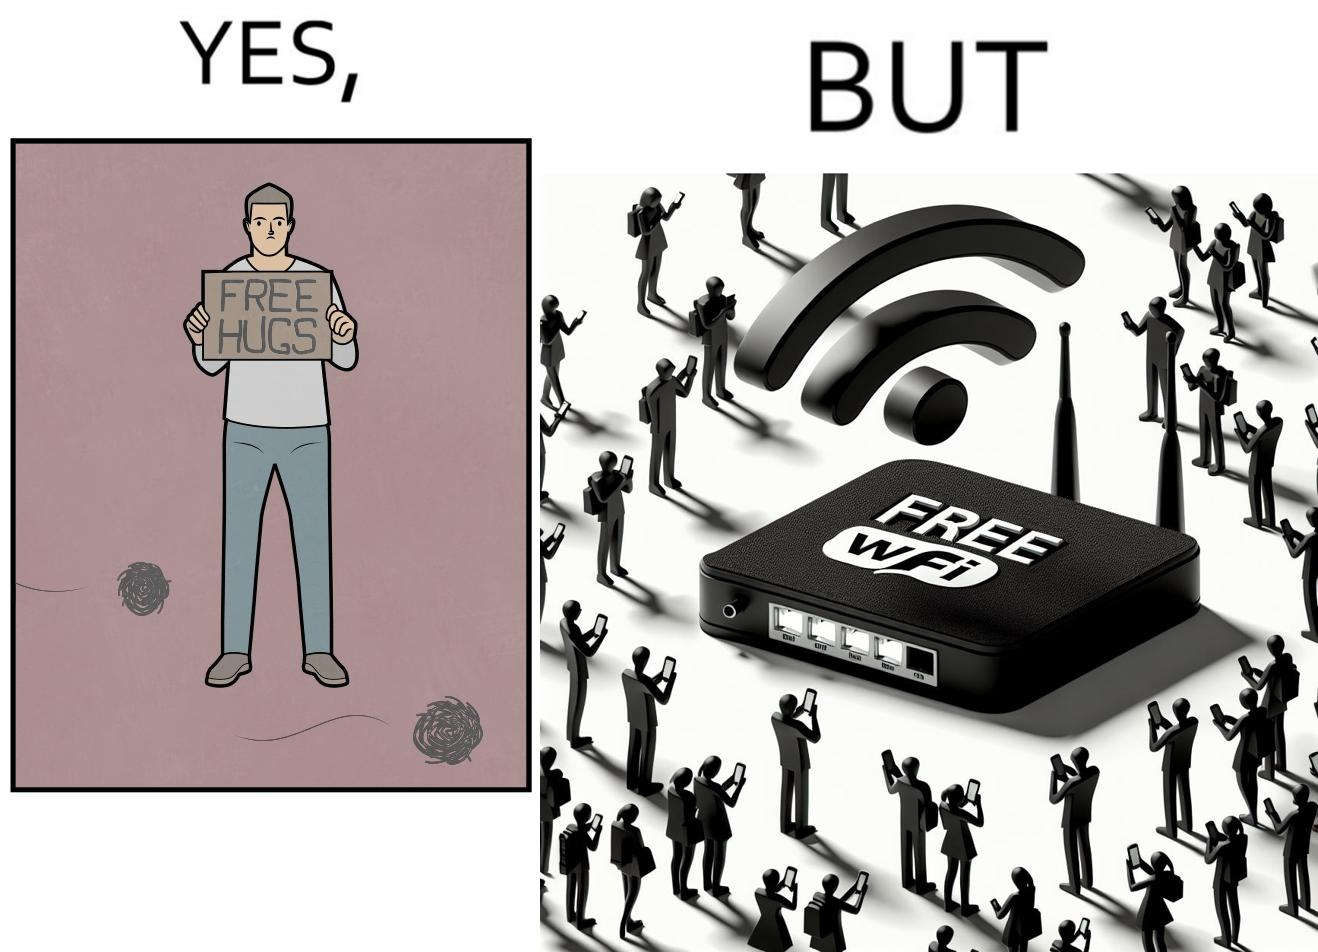Why is this image considered satirical? This image is ironical, as a person holding up a "Free Hugs" sign is standing alone, while an inanimate Wi-fi Router giving "Free Wifi" is surrounded people trying to connect to it. This shows a growing lack of empathy in our society, while showing our increasing dependence on the digital devices in a virtual world. 